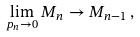<formula> <loc_0><loc_0><loc_500><loc_500>\lim _ { p _ { n } \to 0 } M _ { n } \to M _ { n - 1 } \, ,</formula> 